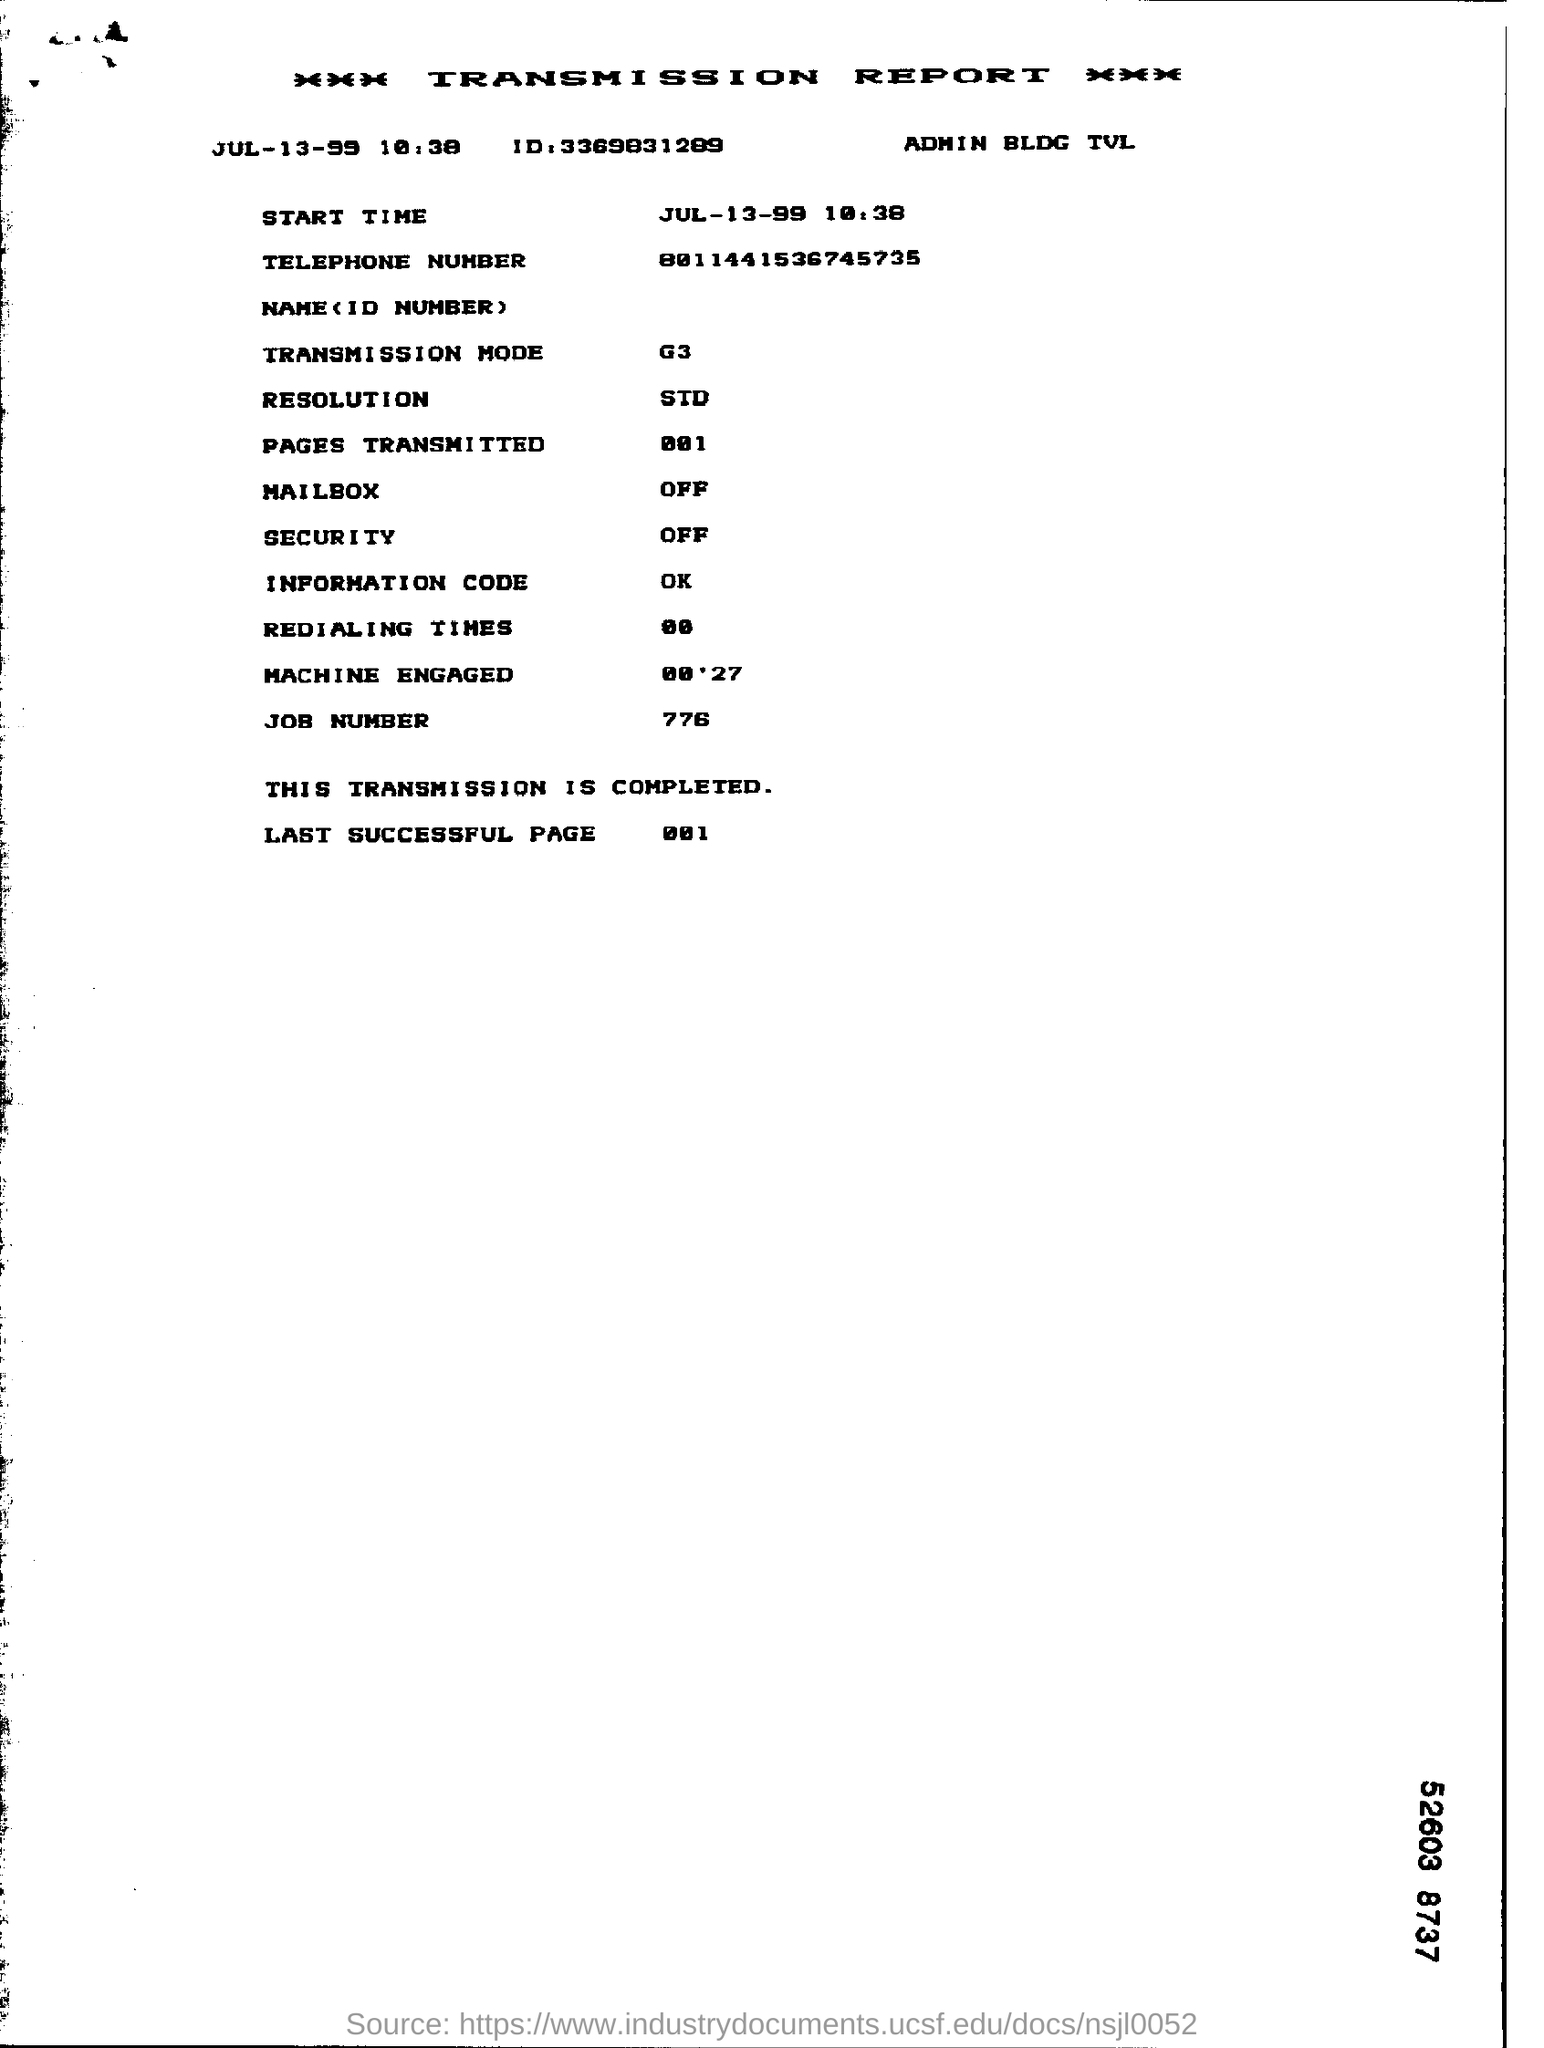Draw attention to some important aspects in this diagram. The transmission report is dated July 13, 1999. The transmission mode mentioned in the report is G3. The resolution mentioned in the report is 720p. The transmission report is complete. The job number mentioned in the report is 776. 